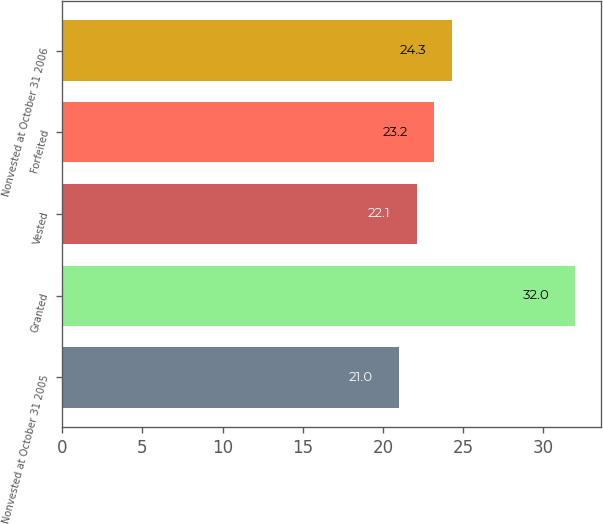<chart> <loc_0><loc_0><loc_500><loc_500><bar_chart><fcel>Nonvested at October 31 2005<fcel>Granted<fcel>Vested<fcel>Forfeited<fcel>Nonvested at October 31 2006<nl><fcel>21<fcel>32<fcel>22.1<fcel>23.2<fcel>24.3<nl></chart> 